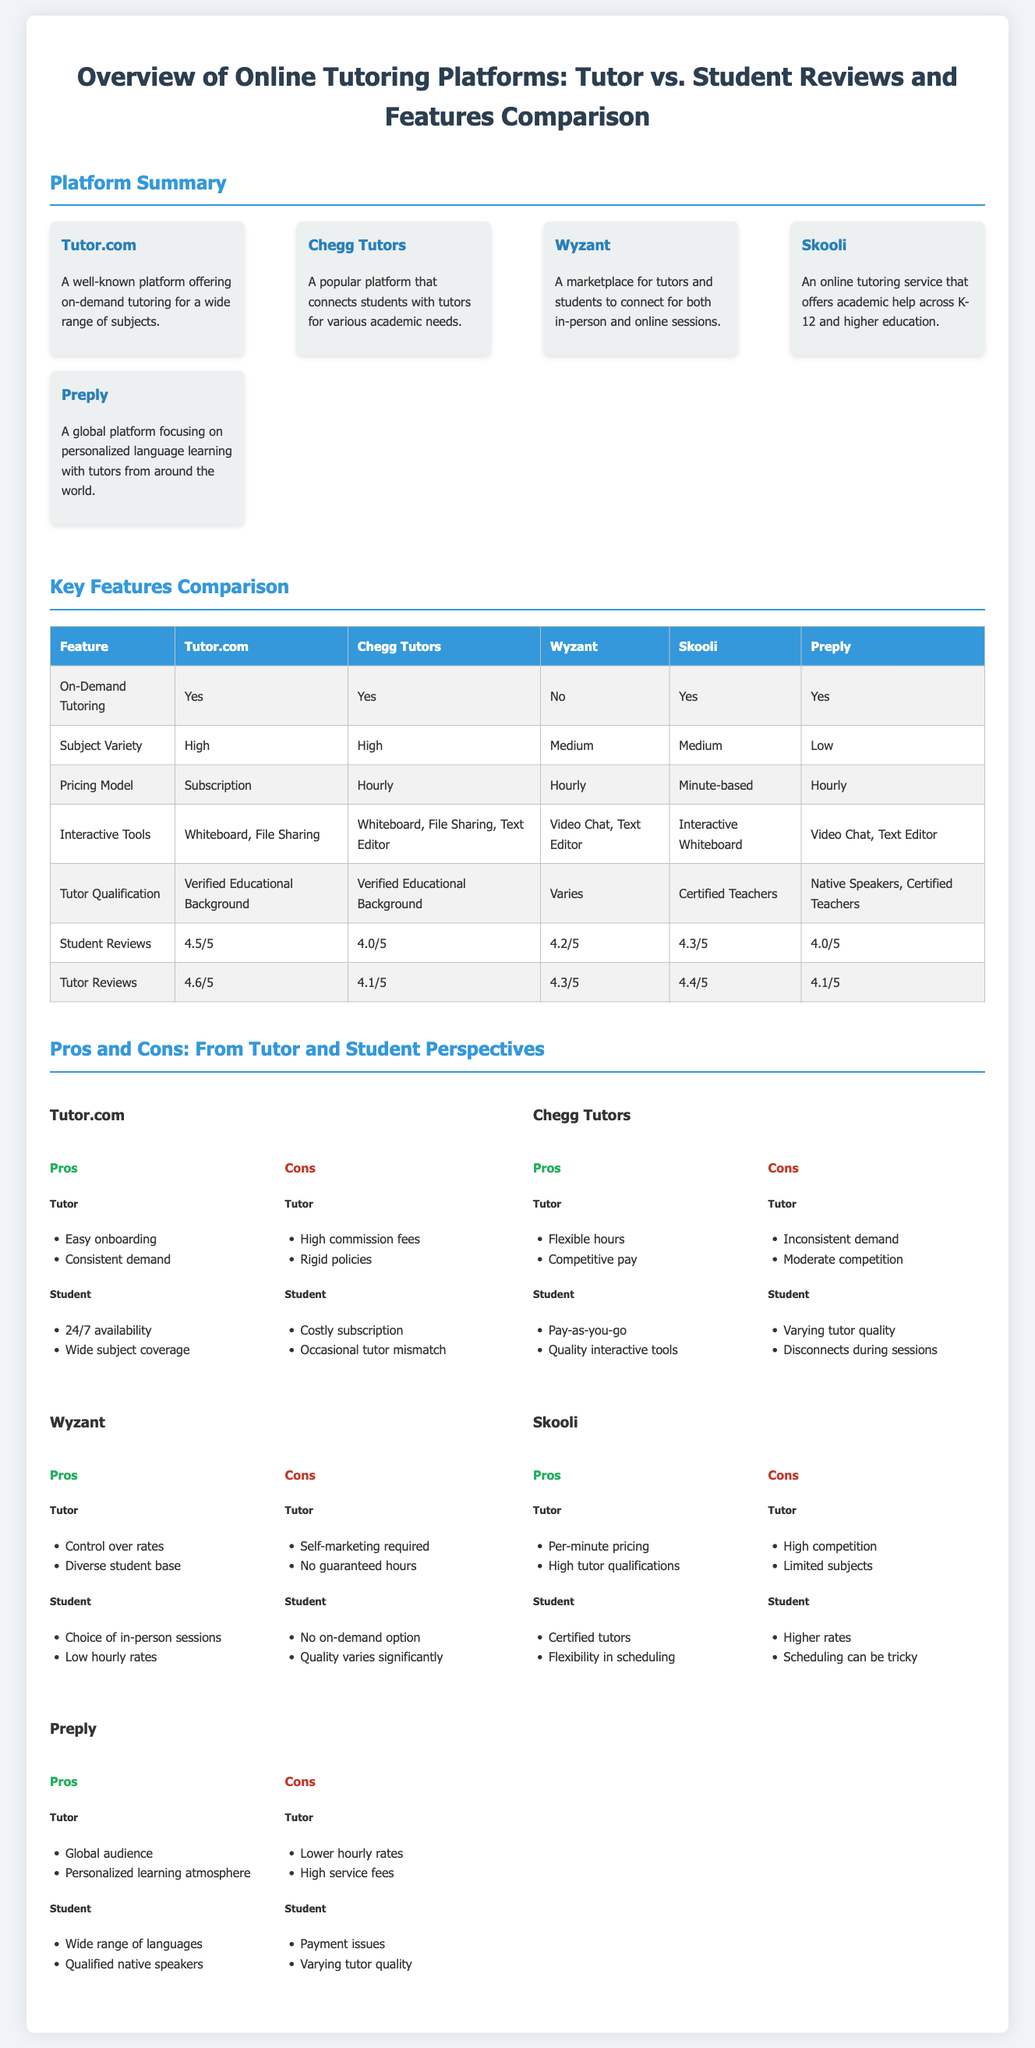What is the average student review rating for Tutor.com? The student review rating for Tutor.com is specified in the comparison table, listed as 4.5/5.
Answer: 4.5/5 What pricing model does Skooli use? The pricing model for Skooli is mentioned in the comparison table as "Minute-based."
Answer: Minute-based How many platforms offer on-demand tutoring? By reviewing the comparison table, we see that Tutor.com, Chegg Tutors, Skooli, and Preply offer on-demand tutoring, totaling four platforms.
Answer: Four What is a pro for students using Wyzant? The document states that one of the pros for students is "Choice of in-person sessions."
Answer: Choice of in-person sessions Which platform has the lowest student review rating? By comparing the student reviews, Chegg Tutors has the lowest rating of 4.0/5.
Answer: 4.0/5 What tool is common between Chegg Tutors and Tutor.com? Both platforms offer "Whiteboard" as an interactive tool listed in the comparison table.
Answer: Whiteboard What is a drawback for tutors on Preply? The document lists one of the cons for tutors on Preply as "Lower hourly rates."
Answer: Lower hourly rates How many platforms are mentioned in the summary section? The summary section consists of five platforms, as seen in the context of the document.
Answer: Five What is the qualification requirement for tutors on Skooli? The comparison table specifies that Skooli tutors must be "Certified Teachers."
Answer: Certified Teachers 